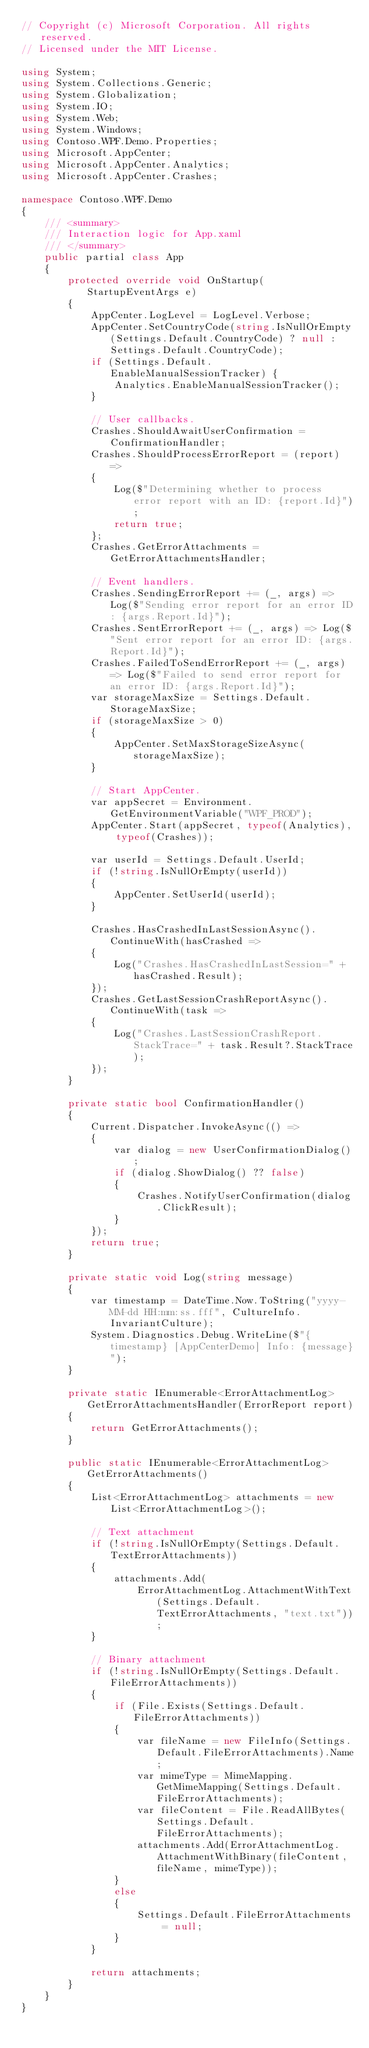<code> <loc_0><loc_0><loc_500><loc_500><_C#_>// Copyright (c) Microsoft Corporation. All rights reserved.
// Licensed under the MIT License.

using System;
using System.Collections.Generic;
using System.Globalization;
using System.IO;
using System.Web;
using System.Windows;
using Contoso.WPF.Demo.Properties;
using Microsoft.AppCenter;
using Microsoft.AppCenter.Analytics;
using Microsoft.AppCenter.Crashes;

namespace Contoso.WPF.Demo
{
    /// <summary>
    /// Interaction logic for App.xaml
    /// </summary>
    public partial class App
    {
        protected override void OnStartup(StartupEventArgs e)
        {
            AppCenter.LogLevel = LogLevel.Verbose;
            AppCenter.SetCountryCode(string.IsNullOrEmpty(Settings.Default.CountryCode) ? null : Settings.Default.CountryCode);
            if (Settings.Default.EnableManualSessionTracker) {
                Analytics.EnableManualSessionTracker();
            }

            // User callbacks.
            Crashes.ShouldAwaitUserConfirmation = ConfirmationHandler;
            Crashes.ShouldProcessErrorReport = (report) =>
            {
                Log($"Determining whether to process error report with an ID: {report.Id}");
                return true;
            };
            Crashes.GetErrorAttachments = GetErrorAttachmentsHandler;

            // Event handlers.
            Crashes.SendingErrorReport += (_, args) => Log($"Sending error report for an error ID: {args.Report.Id}");
            Crashes.SentErrorReport += (_, args) => Log($"Sent error report for an error ID: {args.Report.Id}");
            Crashes.FailedToSendErrorReport += (_, args) => Log($"Failed to send error report for an error ID: {args.Report.Id}");
            var storageMaxSize = Settings.Default.StorageMaxSize;
            if (storageMaxSize > 0)
            {
                AppCenter.SetMaxStorageSizeAsync(storageMaxSize);
            }

            // Start AppCenter.
            var appSecret = Environment.GetEnvironmentVariable("WPF_PROD");
            AppCenter.Start(appSecret, typeof(Analytics), typeof(Crashes));

            var userId = Settings.Default.UserId;
            if (!string.IsNullOrEmpty(userId))
            {
                AppCenter.SetUserId(userId);
            }

            Crashes.HasCrashedInLastSessionAsync().ContinueWith(hasCrashed =>
            {
                Log("Crashes.HasCrashedInLastSession=" + hasCrashed.Result);
            });
            Crashes.GetLastSessionCrashReportAsync().ContinueWith(task =>
            {
                Log("Crashes.LastSessionCrashReport.StackTrace=" + task.Result?.StackTrace);
            });
        }

        private static bool ConfirmationHandler()
        {
            Current.Dispatcher.InvokeAsync(() =>
            {
                var dialog = new UserConfirmationDialog();
                if (dialog.ShowDialog() ?? false)
                {
                    Crashes.NotifyUserConfirmation(dialog.ClickResult);
                }
            });
            return true;
        }

        private static void Log(string message)
        {
            var timestamp = DateTime.Now.ToString("yyyy-MM-dd HH:mm:ss.fff", CultureInfo.InvariantCulture);
            System.Diagnostics.Debug.WriteLine($"{timestamp} [AppCenterDemo] Info: {message}");
        }

        private static IEnumerable<ErrorAttachmentLog> GetErrorAttachmentsHandler(ErrorReport report)
        {
            return GetErrorAttachments();
        }

        public static IEnumerable<ErrorAttachmentLog> GetErrorAttachments()
        {
            List<ErrorAttachmentLog> attachments = new List<ErrorAttachmentLog>();

            // Text attachment
            if (!string.IsNullOrEmpty(Settings.Default.TextErrorAttachments))
            {
                attachments.Add(
                    ErrorAttachmentLog.AttachmentWithText(Settings.Default.TextErrorAttachments, "text.txt"));
            }

            // Binary attachment
            if (!string.IsNullOrEmpty(Settings.Default.FileErrorAttachments))
            {
                if (File.Exists(Settings.Default.FileErrorAttachments))
                {
                    var fileName = new FileInfo(Settings.Default.FileErrorAttachments).Name;
                    var mimeType = MimeMapping.GetMimeMapping(Settings.Default.FileErrorAttachments);
                    var fileContent = File.ReadAllBytes(Settings.Default.FileErrorAttachments);
                    attachments.Add(ErrorAttachmentLog.AttachmentWithBinary(fileContent, fileName, mimeType));
                }
                else
                {
                    Settings.Default.FileErrorAttachments = null;
                }
            }

            return attachments;
        }
    }
}
</code> 